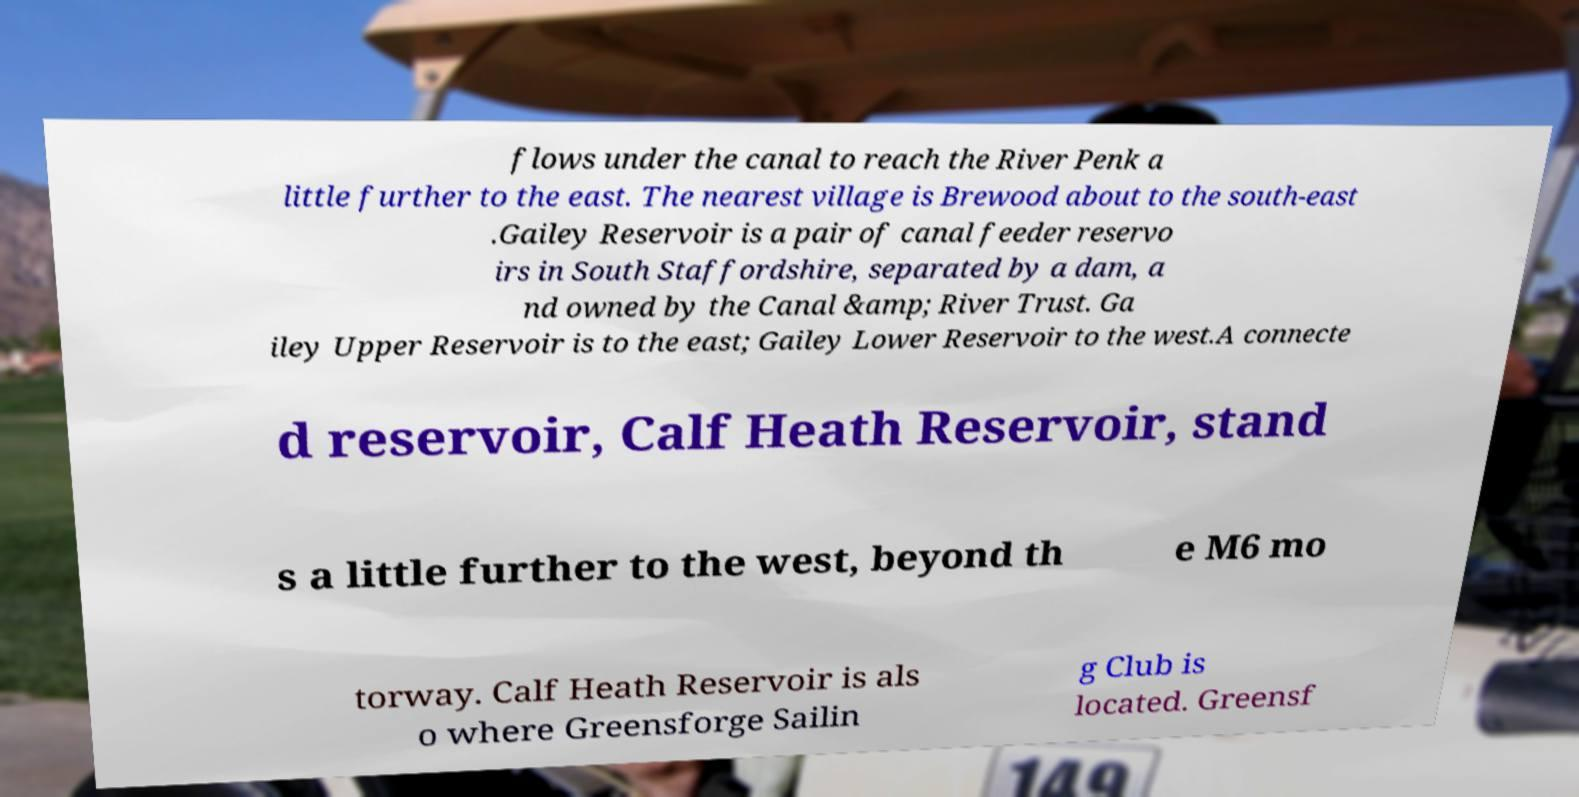Can you read and provide the text displayed in the image?This photo seems to have some interesting text. Can you extract and type it out for me? flows under the canal to reach the River Penk a little further to the east. The nearest village is Brewood about to the south-east .Gailey Reservoir is a pair of canal feeder reservo irs in South Staffordshire, separated by a dam, a nd owned by the Canal &amp; River Trust. Ga iley Upper Reservoir is to the east; Gailey Lower Reservoir to the west.A connecte d reservoir, Calf Heath Reservoir, stand s a little further to the west, beyond th e M6 mo torway. Calf Heath Reservoir is als o where Greensforge Sailin g Club is located. Greensf 